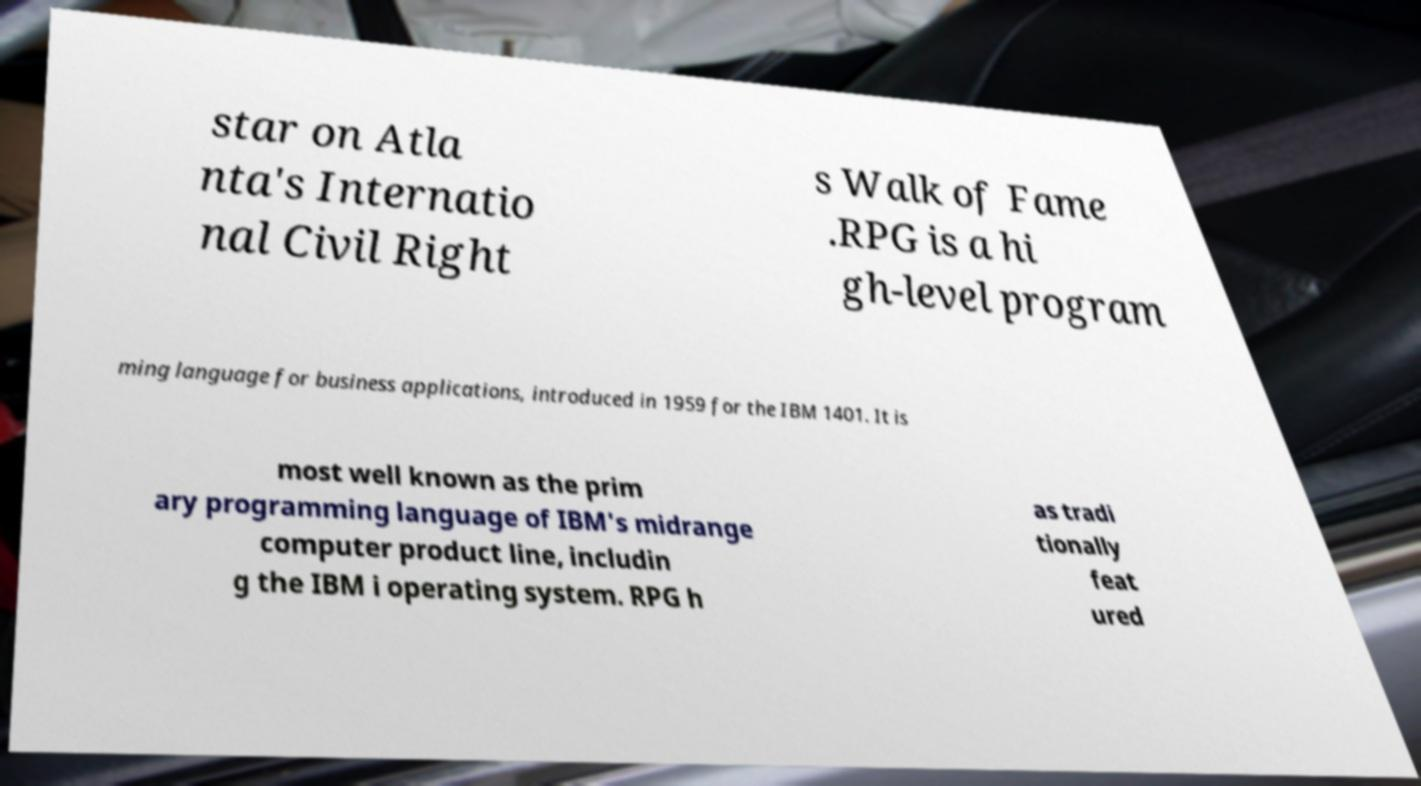There's text embedded in this image that I need extracted. Can you transcribe it verbatim? star on Atla nta's Internatio nal Civil Right s Walk of Fame .RPG is a hi gh-level program ming language for business applications, introduced in 1959 for the IBM 1401. It is most well known as the prim ary programming language of IBM's midrange computer product line, includin g the IBM i operating system. RPG h as tradi tionally feat ured 